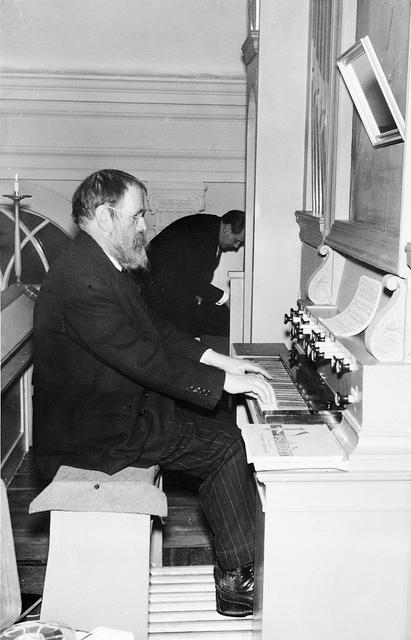How many people are there?
Give a very brief answer. 2. How many skiiers are standing to the right of the train car?
Give a very brief answer. 0. 